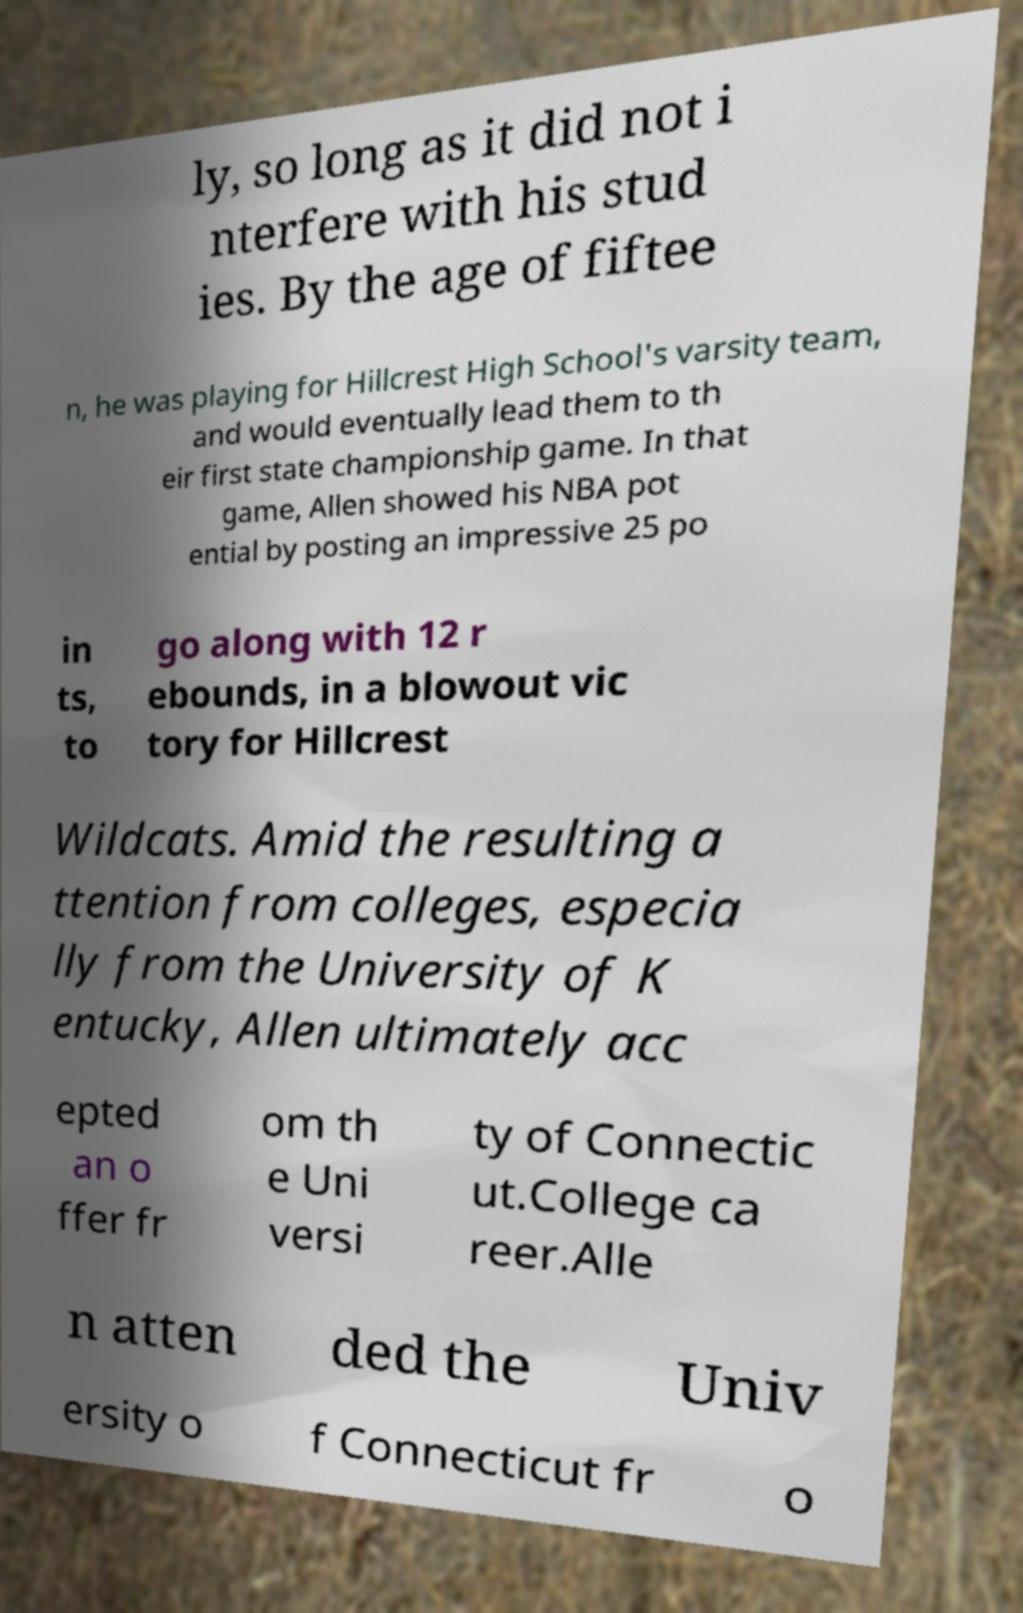Please read and relay the text visible in this image. What does it say? ly, so long as it did not i nterfere with his stud ies. By the age of fiftee n, he was playing for Hillcrest High School's varsity team, and would eventually lead them to th eir first state championship game. In that game, Allen showed his NBA pot ential by posting an impressive 25 po in ts, to go along with 12 r ebounds, in a blowout vic tory for Hillcrest Wildcats. Amid the resulting a ttention from colleges, especia lly from the University of K entucky, Allen ultimately acc epted an o ffer fr om th e Uni versi ty of Connectic ut.College ca reer.Alle n atten ded the Univ ersity o f Connecticut fr o 